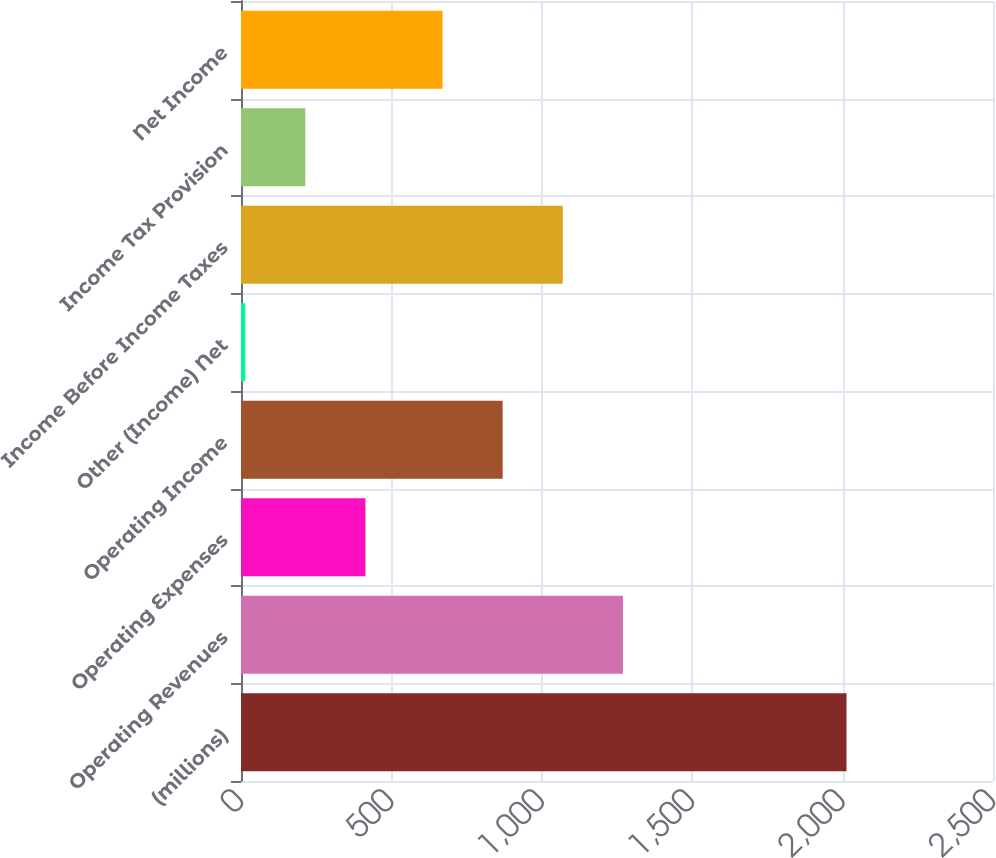<chart> <loc_0><loc_0><loc_500><loc_500><bar_chart><fcel>(millions)<fcel>Operating Revenues<fcel>Operating Expenses<fcel>Operating Income<fcel>Other (Income) Net<fcel>Income Before Income Taxes<fcel>Income Tax Provision<fcel>Net Income<nl><fcel>2013<fcel>1269.7<fcel>413.8<fcel>869.9<fcel>14<fcel>1069.8<fcel>213.9<fcel>670<nl></chart> 